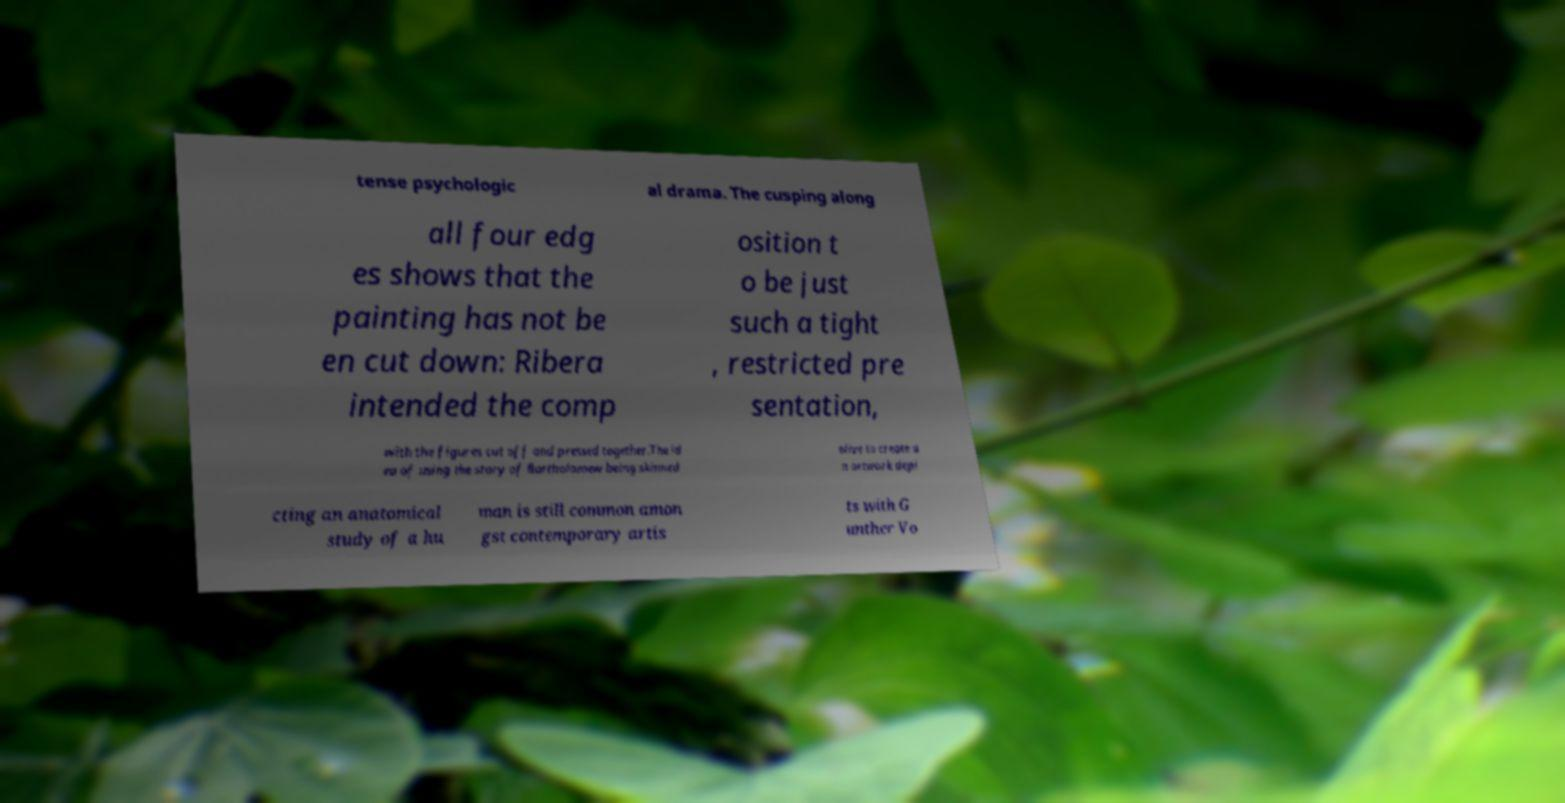Could you extract and type out the text from this image? tense psychologic al drama. The cusping along all four edg es shows that the painting has not be en cut down: Ribera intended the comp osition t o be just such a tight , restricted pre sentation, with the figures cut off and pressed together.The id ea of using the story of Bartholomew being skinned alive to create a n artwork depi cting an anatomical study of a hu man is still common amon gst contemporary artis ts with G unther Vo 